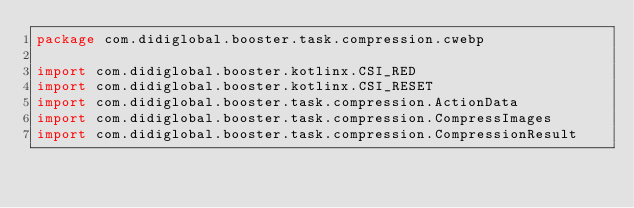<code> <loc_0><loc_0><loc_500><loc_500><_Kotlin_>package com.didiglobal.booster.task.compression.cwebp

import com.didiglobal.booster.kotlinx.CSI_RED
import com.didiglobal.booster.kotlinx.CSI_RESET
import com.didiglobal.booster.task.compression.ActionData
import com.didiglobal.booster.task.compression.CompressImages
import com.didiglobal.booster.task.compression.CompressionResult</code> 